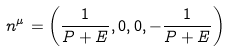<formula> <loc_0><loc_0><loc_500><loc_500>n ^ { \mu } = \left ( { \frac { 1 } { P + E } } , 0 , 0 , - { \frac { 1 } { P + E } } \right )</formula> 